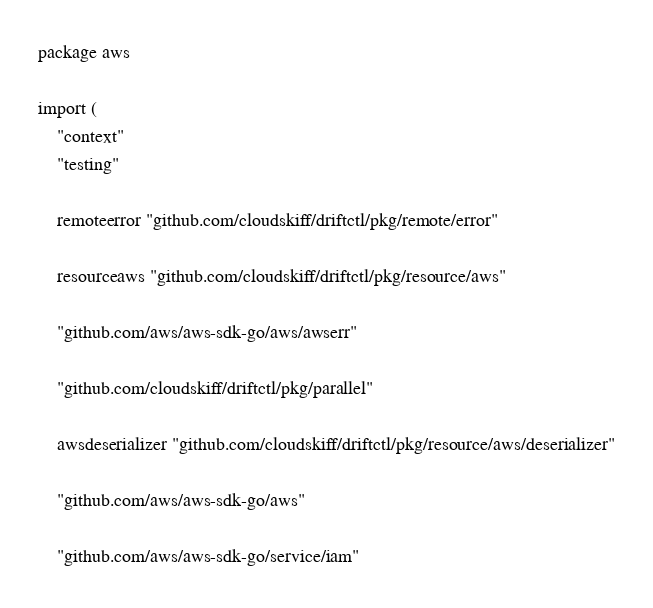Convert code to text. <code><loc_0><loc_0><loc_500><loc_500><_Go_>package aws

import (
	"context"
	"testing"

	remoteerror "github.com/cloudskiff/driftctl/pkg/remote/error"

	resourceaws "github.com/cloudskiff/driftctl/pkg/resource/aws"

	"github.com/aws/aws-sdk-go/aws/awserr"

	"github.com/cloudskiff/driftctl/pkg/parallel"

	awsdeserializer "github.com/cloudskiff/driftctl/pkg/resource/aws/deserializer"

	"github.com/aws/aws-sdk-go/aws"

	"github.com/aws/aws-sdk-go/service/iam"
</code> 